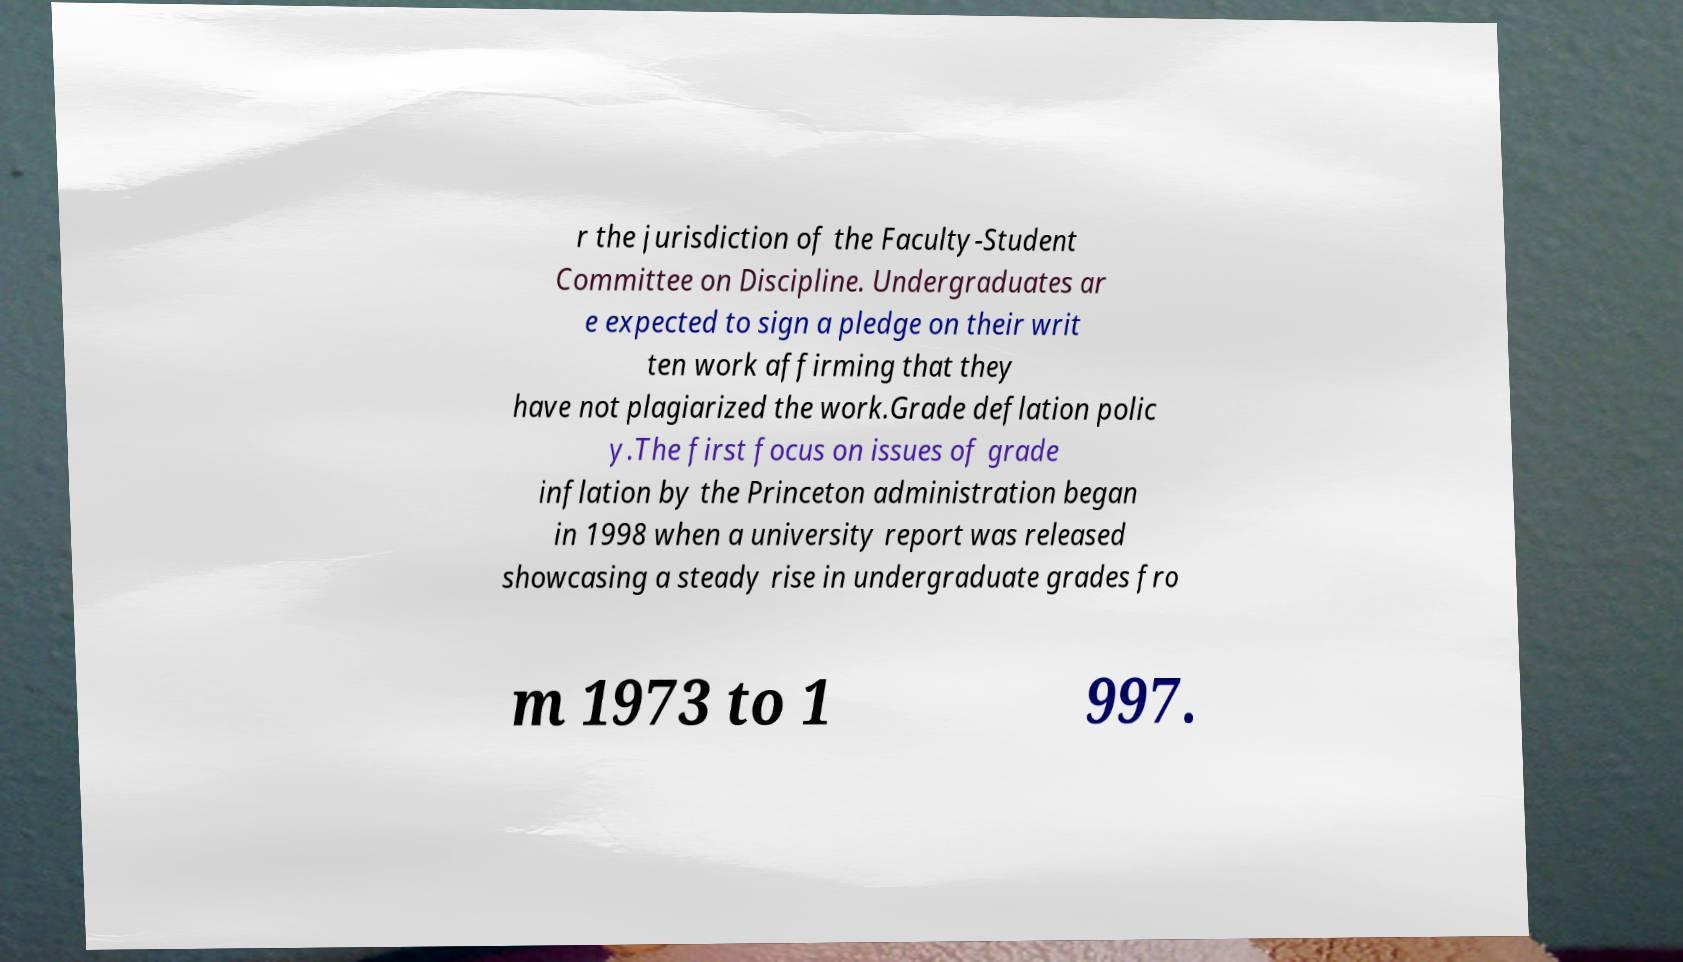Can you accurately transcribe the text from the provided image for me? r the jurisdiction of the Faculty-Student Committee on Discipline. Undergraduates ar e expected to sign a pledge on their writ ten work affirming that they have not plagiarized the work.Grade deflation polic y.The first focus on issues of grade inflation by the Princeton administration began in 1998 when a university report was released showcasing a steady rise in undergraduate grades fro m 1973 to 1 997. 